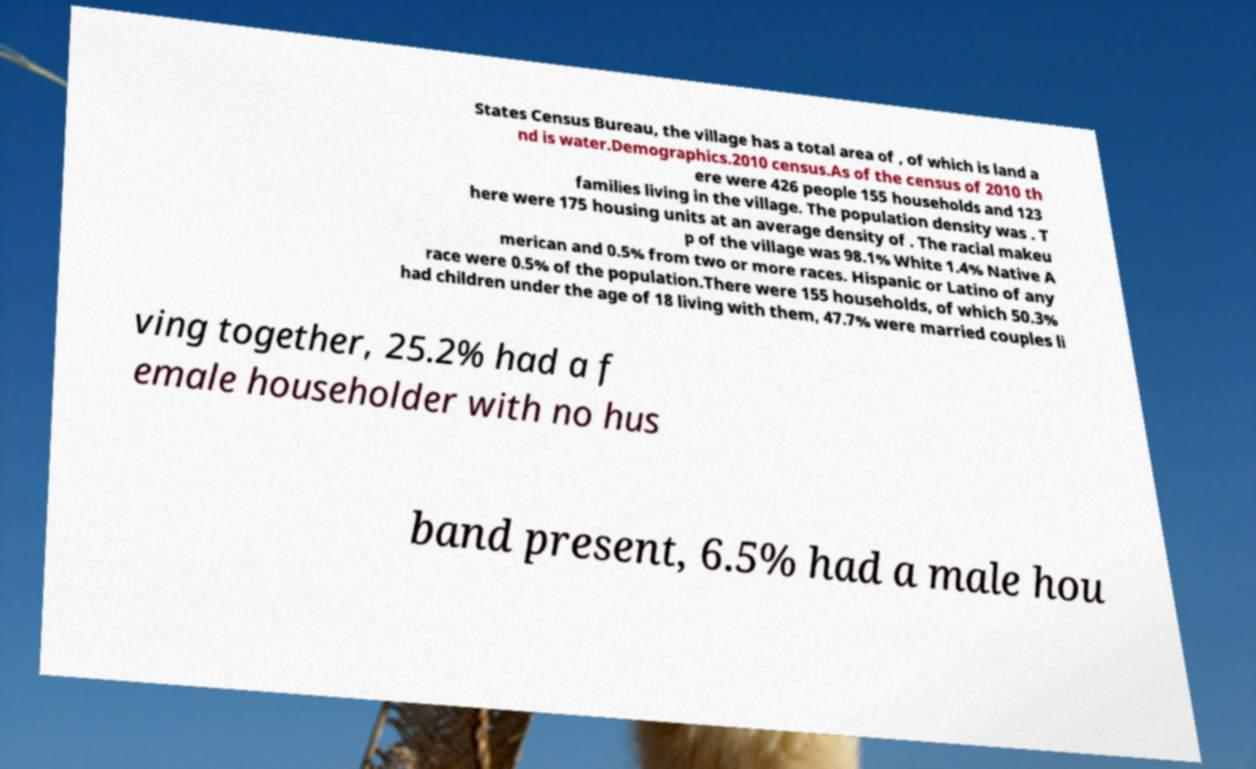Can you read and provide the text displayed in the image?This photo seems to have some interesting text. Can you extract and type it out for me? States Census Bureau, the village has a total area of , of which is land a nd is water.Demographics.2010 census.As of the census of 2010 th ere were 426 people 155 households and 123 families living in the village. The population density was . T here were 175 housing units at an average density of . The racial makeu p of the village was 98.1% White 1.4% Native A merican and 0.5% from two or more races. Hispanic or Latino of any race were 0.5% of the population.There were 155 households, of which 50.3% had children under the age of 18 living with them, 47.7% were married couples li ving together, 25.2% had a f emale householder with no hus band present, 6.5% had a male hou 